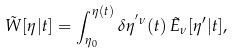<formula> <loc_0><loc_0><loc_500><loc_500>\tilde { W } [ \eta | t ] = \int _ { \eta _ { 0 } } ^ { \eta ( t ) } \delta \eta ^ { ^ { \prime } \nu } ( t ) \, \tilde { E } _ { \nu } [ \eta ^ { \prime } | t ] ,</formula> 